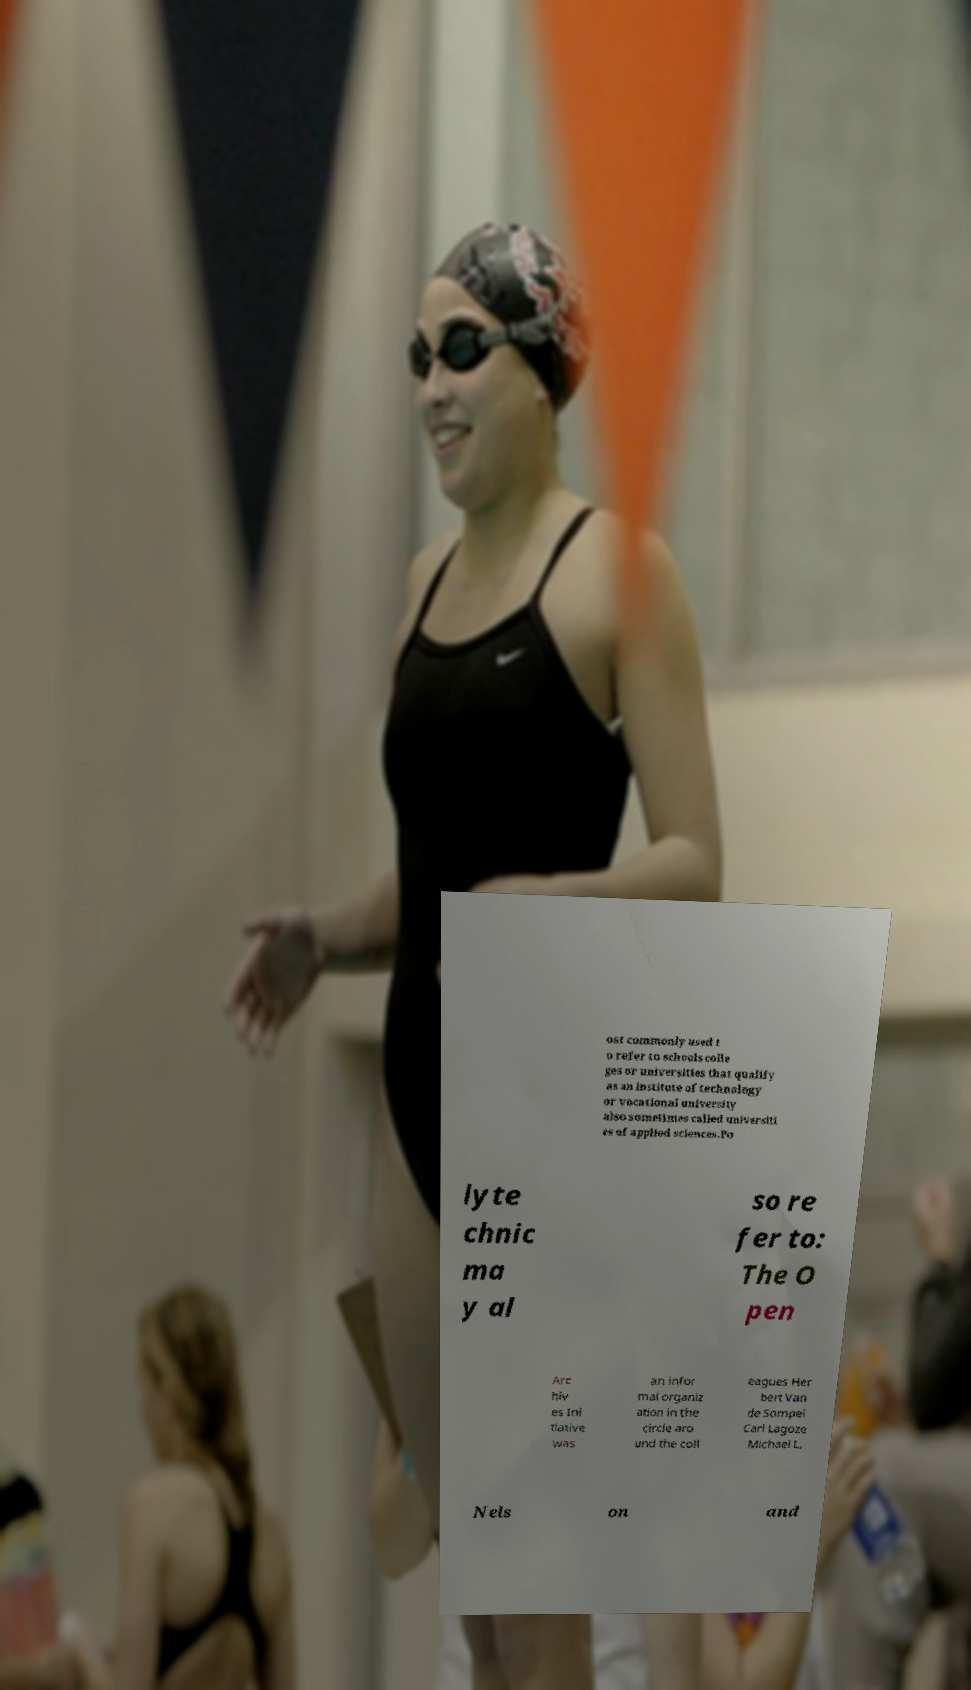Please identify and transcribe the text found in this image. ost commonly used t o refer to schools colle ges or universities that qualify as an institute of technology or vocational university also sometimes called universiti es of applied sciences.Po lyte chnic ma y al so re fer to: The O pen Arc hiv es Ini tiative was an infor mal organiz ation in the circle aro und the coll eagues Her bert Van de Sompel Carl Lagoze Michael L. Nels on and 